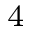<formula> <loc_0><loc_0><loc_500><loc_500>_ { 4 }</formula> 